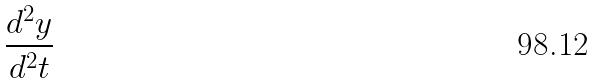<formula> <loc_0><loc_0><loc_500><loc_500>\frac { d ^ { 2 } y } { d ^ { 2 } t }</formula> 